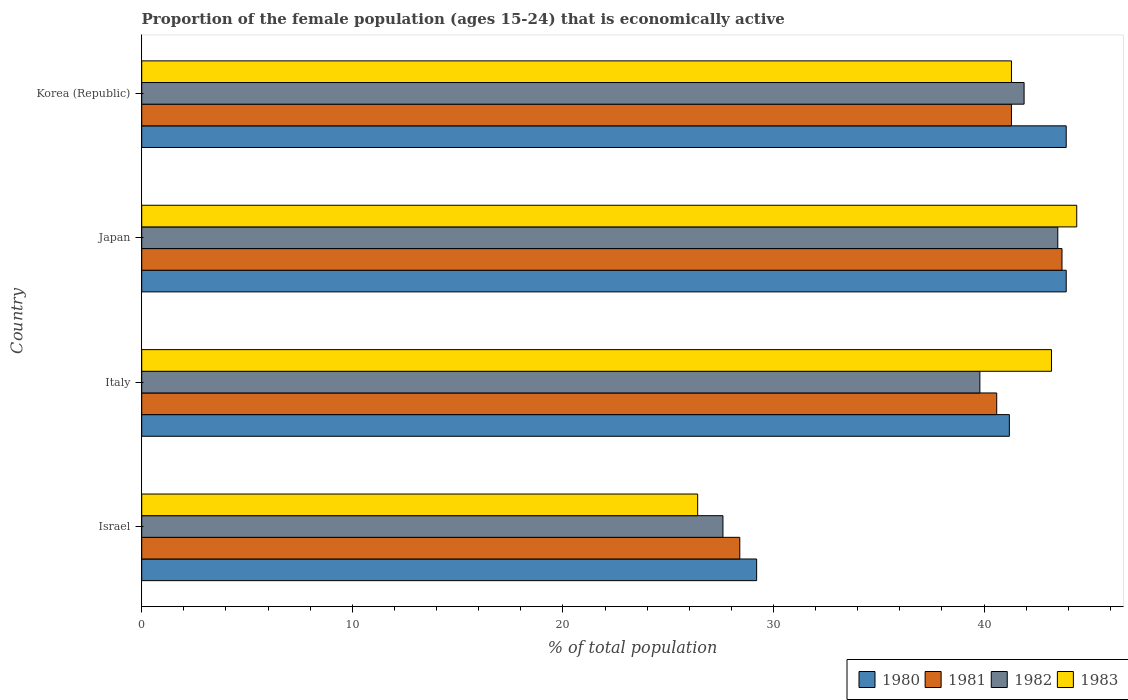How many groups of bars are there?
Your response must be concise. 4. Are the number of bars per tick equal to the number of legend labels?
Offer a terse response. Yes. What is the proportion of the female population that is economically active in 1982 in Japan?
Provide a short and direct response. 43.5. Across all countries, what is the maximum proportion of the female population that is economically active in 1983?
Provide a succinct answer. 44.4. Across all countries, what is the minimum proportion of the female population that is economically active in 1980?
Keep it short and to the point. 29.2. In which country was the proportion of the female population that is economically active in 1980 minimum?
Give a very brief answer. Israel. What is the total proportion of the female population that is economically active in 1980 in the graph?
Your response must be concise. 158.2. What is the difference between the proportion of the female population that is economically active in 1982 in Israel and that in Japan?
Your answer should be very brief. -15.9. What is the difference between the proportion of the female population that is economically active in 1981 in Italy and the proportion of the female population that is economically active in 1980 in Korea (Republic)?
Provide a short and direct response. -3.3. What is the average proportion of the female population that is economically active in 1981 per country?
Provide a succinct answer. 38.5. What is the difference between the proportion of the female population that is economically active in 1982 and proportion of the female population that is economically active in 1983 in Italy?
Ensure brevity in your answer.  -3.4. In how many countries, is the proportion of the female population that is economically active in 1981 greater than 36 %?
Your answer should be very brief. 3. What is the ratio of the proportion of the female population that is economically active in 1982 in Israel to that in Korea (Republic)?
Ensure brevity in your answer.  0.66. What is the difference between the highest and the second highest proportion of the female population that is economically active in 1982?
Give a very brief answer. 1.6. What is the difference between the highest and the lowest proportion of the female population that is economically active in 1981?
Keep it short and to the point. 15.3. In how many countries, is the proportion of the female population that is economically active in 1983 greater than the average proportion of the female population that is economically active in 1983 taken over all countries?
Offer a terse response. 3. Is the sum of the proportion of the female population that is economically active in 1982 in Israel and Italy greater than the maximum proportion of the female population that is economically active in 1980 across all countries?
Ensure brevity in your answer.  Yes. Is it the case that in every country, the sum of the proportion of the female population that is economically active in 1981 and proportion of the female population that is economically active in 1983 is greater than the sum of proportion of the female population that is economically active in 1980 and proportion of the female population that is economically active in 1982?
Keep it short and to the point. No. Is it the case that in every country, the sum of the proportion of the female population that is economically active in 1981 and proportion of the female population that is economically active in 1980 is greater than the proportion of the female population that is economically active in 1982?
Give a very brief answer. Yes. How many bars are there?
Offer a very short reply. 16. Are all the bars in the graph horizontal?
Give a very brief answer. Yes. How many countries are there in the graph?
Offer a very short reply. 4. What is the difference between two consecutive major ticks on the X-axis?
Provide a short and direct response. 10. Does the graph contain grids?
Make the answer very short. No. How many legend labels are there?
Ensure brevity in your answer.  4. How are the legend labels stacked?
Keep it short and to the point. Horizontal. What is the title of the graph?
Keep it short and to the point. Proportion of the female population (ages 15-24) that is economically active. Does "1970" appear as one of the legend labels in the graph?
Provide a succinct answer. No. What is the label or title of the X-axis?
Keep it short and to the point. % of total population. What is the % of total population of 1980 in Israel?
Give a very brief answer. 29.2. What is the % of total population in 1981 in Israel?
Offer a very short reply. 28.4. What is the % of total population in 1982 in Israel?
Your response must be concise. 27.6. What is the % of total population in 1983 in Israel?
Provide a succinct answer. 26.4. What is the % of total population of 1980 in Italy?
Your answer should be very brief. 41.2. What is the % of total population of 1981 in Italy?
Make the answer very short. 40.6. What is the % of total population in 1982 in Italy?
Your answer should be very brief. 39.8. What is the % of total population in 1983 in Italy?
Offer a very short reply. 43.2. What is the % of total population in 1980 in Japan?
Provide a short and direct response. 43.9. What is the % of total population of 1981 in Japan?
Make the answer very short. 43.7. What is the % of total population of 1982 in Japan?
Offer a very short reply. 43.5. What is the % of total population in 1983 in Japan?
Offer a very short reply. 44.4. What is the % of total population of 1980 in Korea (Republic)?
Offer a very short reply. 43.9. What is the % of total population of 1981 in Korea (Republic)?
Offer a very short reply. 41.3. What is the % of total population in 1982 in Korea (Republic)?
Your answer should be very brief. 41.9. What is the % of total population in 1983 in Korea (Republic)?
Your response must be concise. 41.3. Across all countries, what is the maximum % of total population of 1980?
Keep it short and to the point. 43.9. Across all countries, what is the maximum % of total population of 1981?
Offer a terse response. 43.7. Across all countries, what is the maximum % of total population of 1982?
Make the answer very short. 43.5. Across all countries, what is the maximum % of total population of 1983?
Give a very brief answer. 44.4. Across all countries, what is the minimum % of total population in 1980?
Your response must be concise. 29.2. Across all countries, what is the minimum % of total population in 1981?
Keep it short and to the point. 28.4. Across all countries, what is the minimum % of total population in 1982?
Provide a short and direct response. 27.6. Across all countries, what is the minimum % of total population in 1983?
Your answer should be compact. 26.4. What is the total % of total population in 1980 in the graph?
Ensure brevity in your answer.  158.2. What is the total % of total population in 1981 in the graph?
Keep it short and to the point. 154. What is the total % of total population in 1982 in the graph?
Your answer should be very brief. 152.8. What is the total % of total population of 1983 in the graph?
Ensure brevity in your answer.  155.3. What is the difference between the % of total population of 1980 in Israel and that in Italy?
Provide a short and direct response. -12. What is the difference between the % of total population in 1981 in Israel and that in Italy?
Keep it short and to the point. -12.2. What is the difference between the % of total population of 1982 in Israel and that in Italy?
Make the answer very short. -12.2. What is the difference between the % of total population in 1983 in Israel and that in Italy?
Make the answer very short. -16.8. What is the difference between the % of total population in 1980 in Israel and that in Japan?
Make the answer very short. -14.7. What is the difference between the % of total population of 1981 in Israel and that in Japan?
Your answer should be very brief. -15.3. What is the difference between the % of total population in 1982 in Israel and that in Japan?
Offer a terse response. -15.9. What is the difference between the % of total population in 1980 in Israel and that in Korea (Republic)?
Offer a terse response. -14.7. What is the difference between the % of total population in 1981 in Israel and that in Korea (Republic)?
Provide a succinct answer. -12.9. What is the difference between the % of total population of 1982 in Israel and that in Korea (Republic)?
Your answer should be compact. -14.3. What is the difference between the % of total population of 1983 in Israel and that in Korea (Republic)?
Offer a very short reply. -14.9. What is the difference between the % of total population in 1982 in Italy and that in Japan?
Provide a succinct answer. -3.7. What is the difference between the % of total population in 1983 in Italy and that in Korea (Republic)?
Your response must be concise. 1.9. What is the difference between the % of total population of 1982 in Japan and that in Korea (Republic)?
Provide a succinct answer. 1.6. What is the difference between the % of total population of 1980 in Israel and the % of total population of 1981 in Italy?
Ensure brevity in your answer.  -11.4. What is the difference between the % of total population of 1981 in Israel and the % of total population of 1982 in Italy?
Keep it short and to the point. -11.4. What is the difference between the % of total population in 1981 in Israel and the % of total population in 1983 in Italy?
Provide a succinct answer. -14.8. What is the difference between the % of total population of 1982 in Israel and the % of total population of 1983 in Italy?
Offer a very short reply. -15.6. What is the difference between the % of total population in 1980 in Israel and the % of total population in 1982 in Japan?
Your answer should be very brief. -14.3. What is the difference between the % of total population of 1980 in Israel and the % of total population of 1983 in Japan?
Offer a very short reply. -15.2. What is the difference between the % of total population of 1981 in Israel and the % of total population of 1982 in Japan?
Make the answer very short. -15.1. What is the difference between the % of total population in 1982 in Israel and the % of total population in 1983 in Japan?
Offer a terse response. -16.8. What is the difference between the % of total population of 1981 in Israel and the % of total population of 1982 in Korea (Republic)?
Make the answer very short. -13.5. What is the difference between the % of total population of 1981 in Israel and the % of total population of 1983 in Korea (Republic)?
Provide a short and direct response. -12.9. What is the difference between the % of total population of 1982 in Israel and the % of total population of 1983 in Korea (Republic)?
Offer a very short reply. -13.7. What is the difference between the % of total population of 1980 in Italy and the % of total population of 1981 in Japan?
Ensure brevity in your answer.  -2.5. What is the difference between the % of total population of 1980 in Italy and the % of total population of 1982 in Japan?
Make the answer very short. -2.3. What is the difference between the % of total population in 1981 in Italy and the % of total population in 1982 in Japan?
Your answer should be very brief. -2.9. What is the difference between the % of total population in 1982 in Italy and the % of total population in 1983 in Japan?
Offer a very short reply. -4.6. What is the difference between the % of total population of 1981 in Italy and the % of total population of 1983 in Korea (Republic)?
Keep it short and to the point. -0.7. What is the difference between the % of total population in 1980 in Japan and the % of total population in 1981 in Korea (Republic)?
Your response must be concise. 2.6. What is the difference between the % of total population in 1980 in Japan and the % of total population in 1982 in Korea (Republic)?
Offer a terse response. 2. What is the difference between the % of total population of 1980 in Japan and the % of total population of 1983 in Korea (Republic)?
Your response must be concise. 2.6. What is the difference between the % of total population in 1981 in Japan and the % of total population in 1982 in Korea (Republic)?
Provide a short and direct response. 1.8. What is the difference between the % of total population of 1982 in Japan and the % of total population of 1983 in Korea (Republic)?
Offer a very short reply. 2.2. What is the average % of total population in 1980 per country?
Make the answer very short. 39.55. What is the average % of total population of 1981 per country?
Offer a very short reply. 38.5. What is the average % of total population of 1982 per country?
Give a very brief answer. 38.2. What is the average % of total population of 1983 per country?
Make the answer very short. 38.83. What is the difference between the % of total population of 1981 and % of total population of 1982 in Israel?
Offer a terse response. 0.8. What is the difference between the % of total population of 1982 and % of total population of 1983 in Israel?
Keep it short and to the point. 1.2. What is the difference between the % of total population in 1981 and % of total population in 1982 in Italy?
Offer a terse response. 0.8. What is the difference between the % of total population in 1982 and % of total population in 1983 in Italy?
Keep it short and to the point. -3.4. What is the difference between the % of total population of 1980 and % of total population of 1981 in Japan?
Your answer should be compact. 0.2. What is the difference between the % of total population of 1981 and % of total population of 1983 in Japan?
Offer a terse response. -0.7. What is the difference between the % of total population of 1980 and % of total population of 1981 in Korea (Republic)?
Offer a terse response. 2.6. What is the difference between the % of total population in 1980 and % of total population in 1982 in Korea (Republic)?
Offer a terse response. 2. What is the difference between the % of total population in 1981 and % of total population in 1982 in Korea (Republic)?
Your response must be concise. -0.6. What is the difference between the % of total population of 1981 and % of total population of 1983 in Korea (Republic)?
Offer a very short reply. 0. What is the ratio of the % of total population in 1980 in Israel to that in Italy?
Your response must be concise. 0.71. What is the ratio of the % of total population in 1981 in Israel to that in Italy?
Provide a short and direct response. 0.7. What is the ratio of the % of total population in 1982 in Israel to that in Italy?
Keep it short and to the point. 0.69. What is the ratio of the % of total population of 1983 in Israel to that in Italy?
Your answer should be compact. 0.61. What is the ratio of the % of total population of 1980 in Israel to that in Japan?
Provide a short and direct response. 0.67. What is the ratio of the % of total population of 1981 in Israel to that in Japan?
Provide a short and direct response. 0.65. What is the ratio of the % of total population of 1982 in Israel to that in Japan?
Provide a succinct answer. 0.63. What is the ratio of the % of total population of 1983 in Israel to that in Japan?
Your answer should be compact. 0.59. What is the ratio of the % of total population of 1980 in Israel to that in Korea (Republic)?
Provide a short and direct response. 0.67. What is the ratio of the % of total population in 1981 in Israel to that in Korea (Republic)?
Provide a short and direct response. 0.69. What is the ratio of the % of total population of 1982 in Israel to that in Korea (Republic)?
Ensure brevity in your answer.  0.66. What is the ratio of the % of total population in 1983 in Israel to that in Korea (Republic)?
Make the answer very short. 0.64. What is the ratio of the % of total population of 1980 in Italy to that in Japan?
Provide a short and direct response. 0.94. What is the ratio of the % of total population in 1981 in Italy to that in Japan?
Make the answer very short. 0.93. What is the ratio of the % of total population in 1982 in Italy to that in Japan?
Keep it short and to the point. 0.91. What is the ratio of the % of total population in 1980 in Italy to that in Korea (Republic)?
Provide a short and direct response. 0.94. What is the ratio of the % of total population of 1981 in Italy to that in Korea (Republic)?
Provide a succinct answer. 0.98. What is the ratio of the % of total population in 1982 in Italy to that in Korea (Republic)?
Your answer should be very brief. 0.95. What is the ratio of the % of total population in 1983 in Italy to that in Korea (Republic)?
Give a very brief answer. 1.05. What is the ratio of the % of total population of 1980 in Japan to that in Korea (Republic)?
Provide a short and direct response. 1. What is the ratio of the % of total population of 1981 in Japan to that in Korea (Republic)?
Ensure brevity in your answer.  1.06. What is the ratio of the % of total population of 1982 in Japan to that in Korea (Republic)?
Offer a very short reply. 1.04. What is the ratio of the % of total population in 1983 in Japan to that in Korea (Republic)?
Make the answer very short. 1.08. What is the difference between the highest and the second highest % of total population of 1980?
Offer a very short reply. 0. What is the difference between the highest and the second highest % of total population in 1981?
Provide a short and direct response. 2.4. What is the difference between the highest and the second highest % of total population of 1983?
Your answer should be compact. 1.2. What is the difference between the highest and the lowest % of total population in 1981?
Provide a short and direct response. 15.3. 